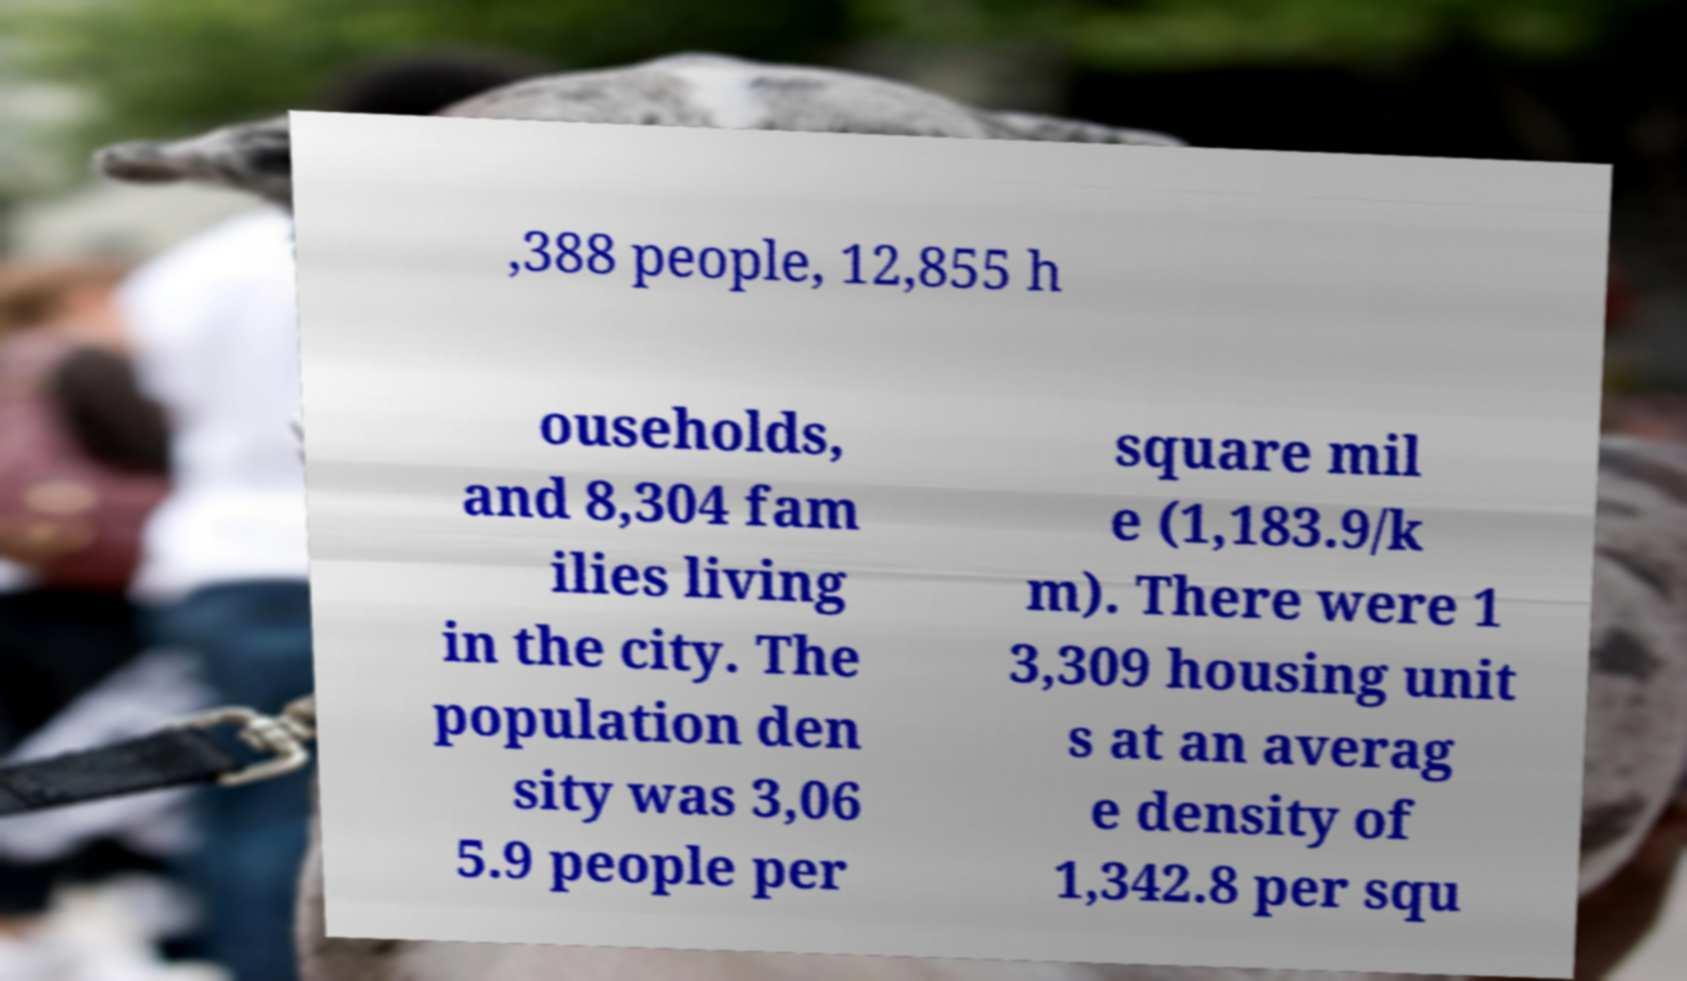What messages or text are displayed in this image? I need them in a readable, typed format. ,388 people, 12,855 h ouseholds, and 8,304 fam ilies living in the city. The population den sity was 3,06 5.9 people per square mil e (1,183.9/k m). There were 1 3,309 housing unit s at an averag e density of 1,342.8 per squ 